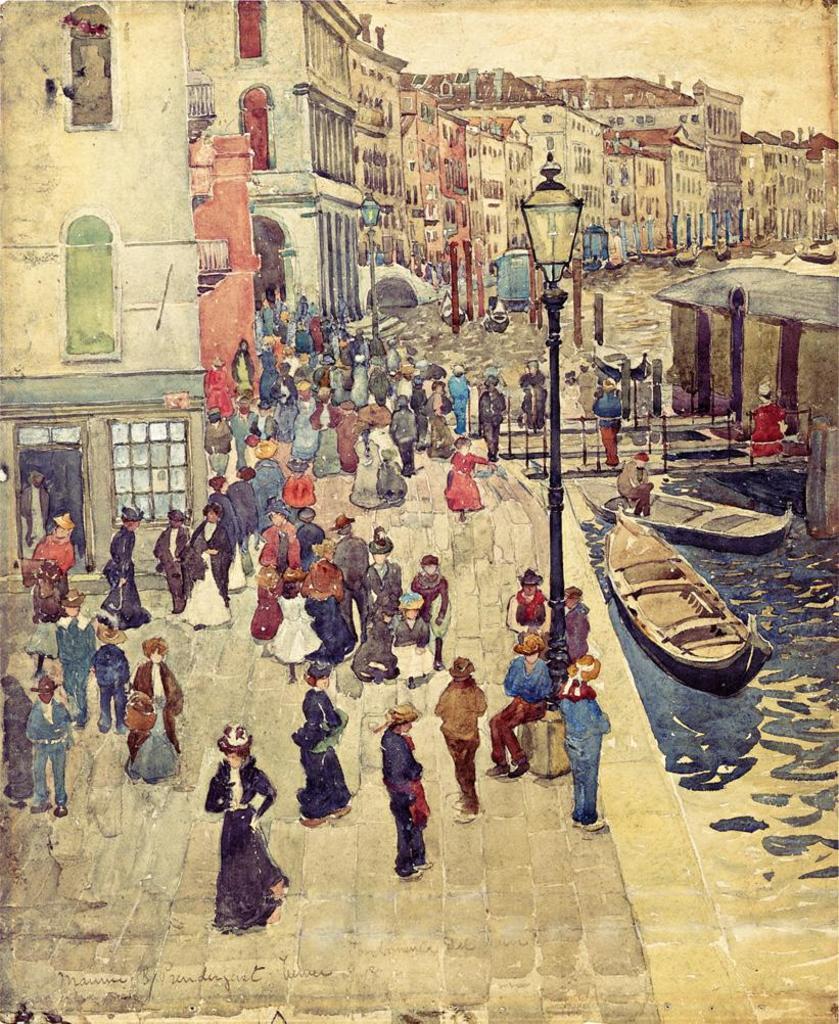Could you give a brief overview of what you see in this image? In this image I can see in depiction of buildings, people, street lights, few poles, few boats and water. 